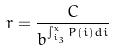<formula> <loc_0><loc_0><loc_500><loc_500>r = \frac { C } { b ^ { \int _ { i _ { 3 } } ^ { x } P ( i ) d i } }</formula> 